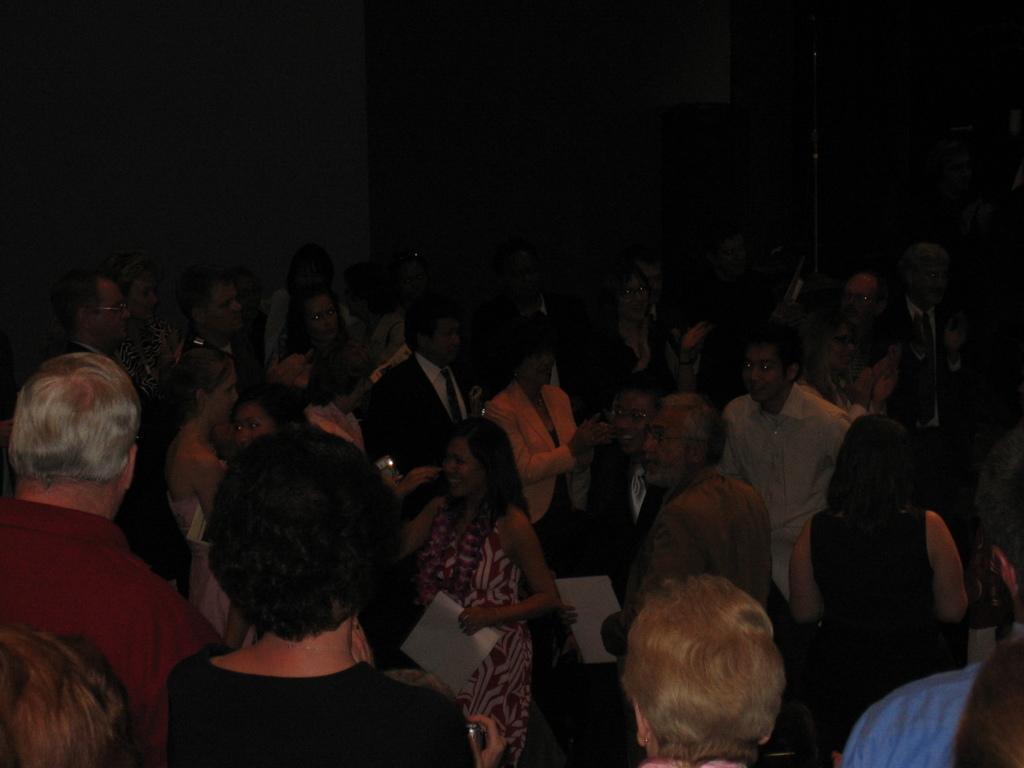Can you describe this image briefly? In this image we can see many people standing and some of them are holding papers. In the background there is a wall. 